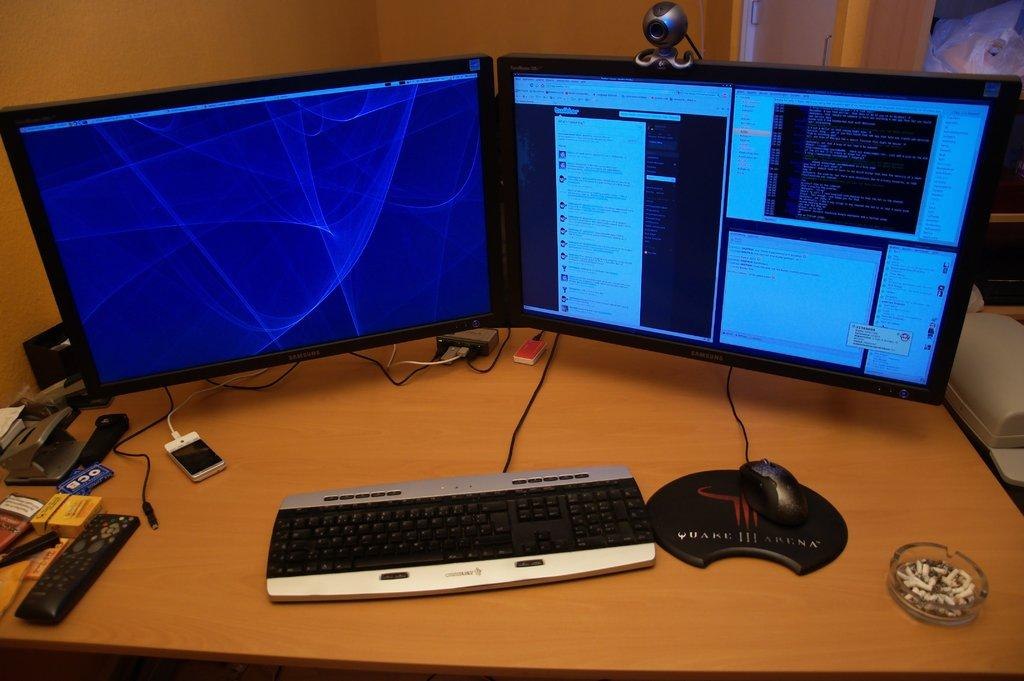<image>
Give a short and clear explanation of the subsequent image. The mouse mat infront of this computer has 111 in the middle of it. 